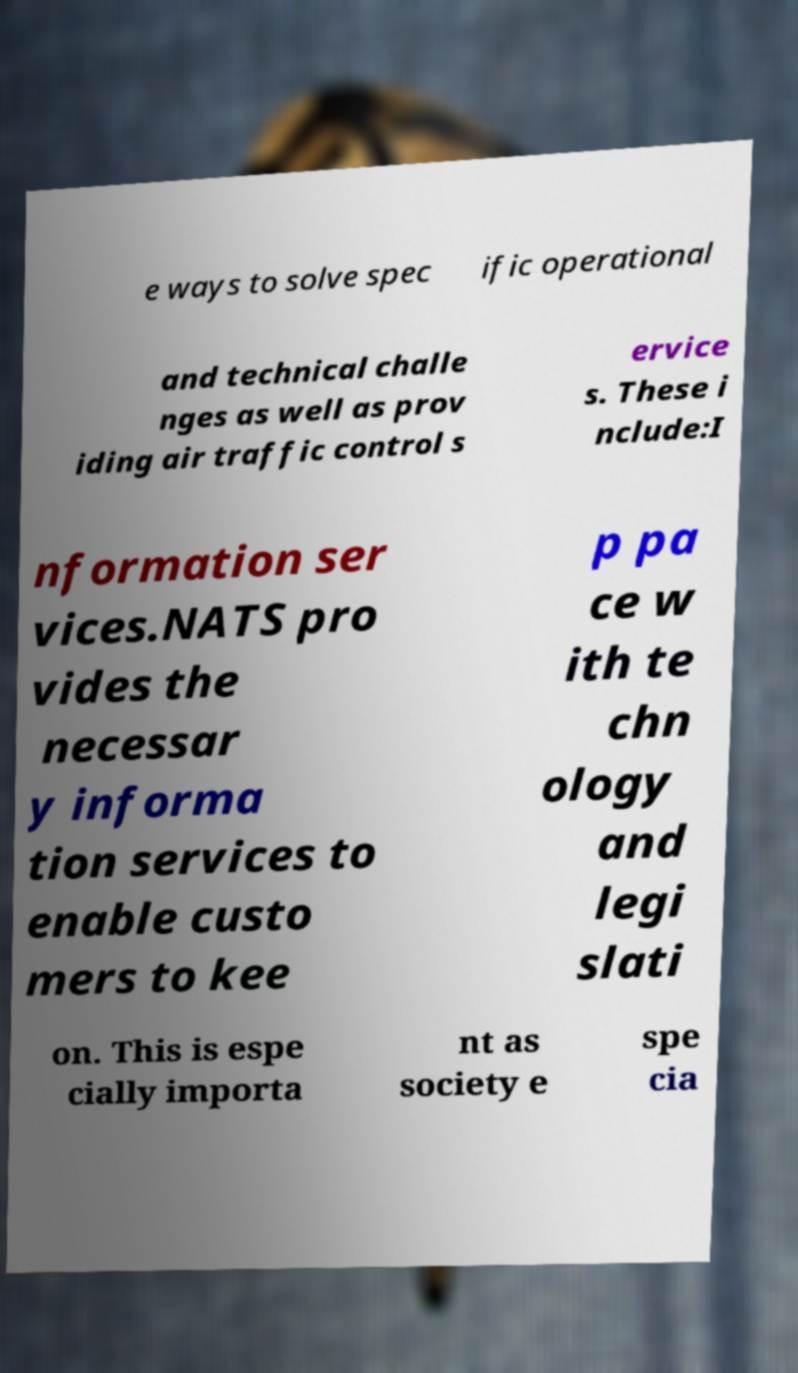I need the written content from this picture converted into text. Can you do that? e ways to solve spec ific operational and technical challe nges as well as prov iding air traffic control s ervice s. These i nclude:I nformation ser vices.NATS pro vides the necessar y informa tion services to enable custo mers to kee p pa ce w ith te chn ology and legi slati on. This is espe cially importa nt as society e spe cia 